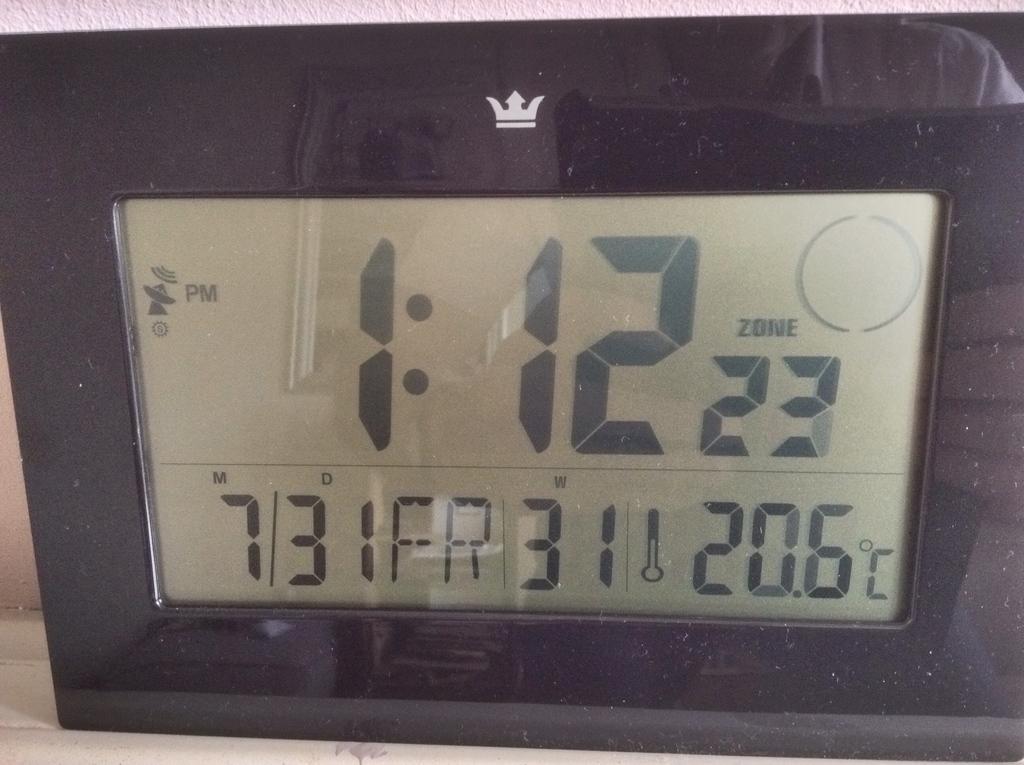In one or two sentences, can you explain what this image depicts? In this picture, we can see an electronic device and some numbers on it. 